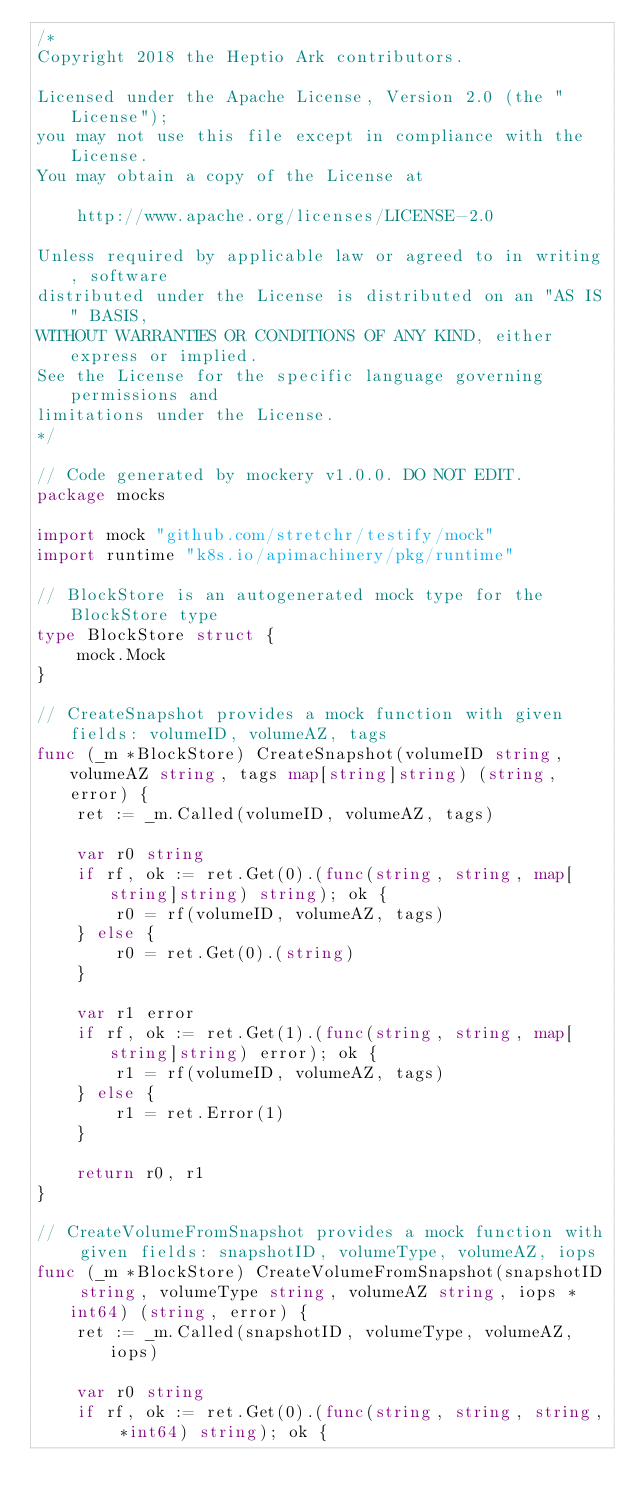Convert code to text. <code><loc_0><loc_0><loc_500><loc_500><_Go_>/*
Copyright 2018 the Heptio Ark contributors.

Licensed under the Apache License, Version 2.0 (the "License");
you may not use this file except in compliance with the License.
You may obtain a copy of the License at

    http://www.apache.org/licenses/LICENSE-2.0

Unless required by applicable law or agreed to in writing, software
distributed under the License is distributed on an "AS IS" BASIS,
WITHOUT WARRANTIES OR CONDITIONS OF ANY KIND, either express or implied.
See the License for the specific language governing permissions and
limitations under the License.
*/

// Code generated by mockery v1.0.0. DO NOT EDIT.
package mocks

import mock "github.com/stretchr/testify/mock"
import runtime "k8s.io/apimachinery/pkg/runtime"

// BlockStore is an autogenerated mock type for the BlockStore type
type BlockStore struct {
	mock.Mock
}

// CreateSnapshot provides a mock function with given fields: volumeID, volumeAZ, tags
func (_m *BlockStore) CreateSnapshot(volumeID string, volumeAZ string, tags map[string]string) (string, error) {
	ret := _m.Called(volumeID, volumeAZ, tags)

	var r0 string
	if rf, ok := ret.Get(0).(func(string, string, map[string]string) string); ok {
		r0 = rf(volumeID, volumeAZ, tags)
	} else {
		r0 = ret.Get(0).(string)
	}

	var r1 error
	if rf, ok := ret.Get(1).(func(string, string, map[string]string) error); ok {
		r1 = rf(volumeID, volumeAZ, tags)
	} else {
		r1 = ret.Error(1)
	}

	return r0, r1
}

// CreateVolumeFromSnapshot provides a mock function with given fields: snapshotID, volumeType, volumeAZ, iops
func (_m *BlockStore) CreateVolumeFromSnapshot(snapshotID string, volumeType string, volumeAZ string, iops *int64) (string, error) {
	ret := _m.Called(snapshotID, volumeType, volumeAZ, iops)

	var r0 string
	if rf, ok := ret.Get(0).(func(string, string, string, *int64) string); ok {</code> 